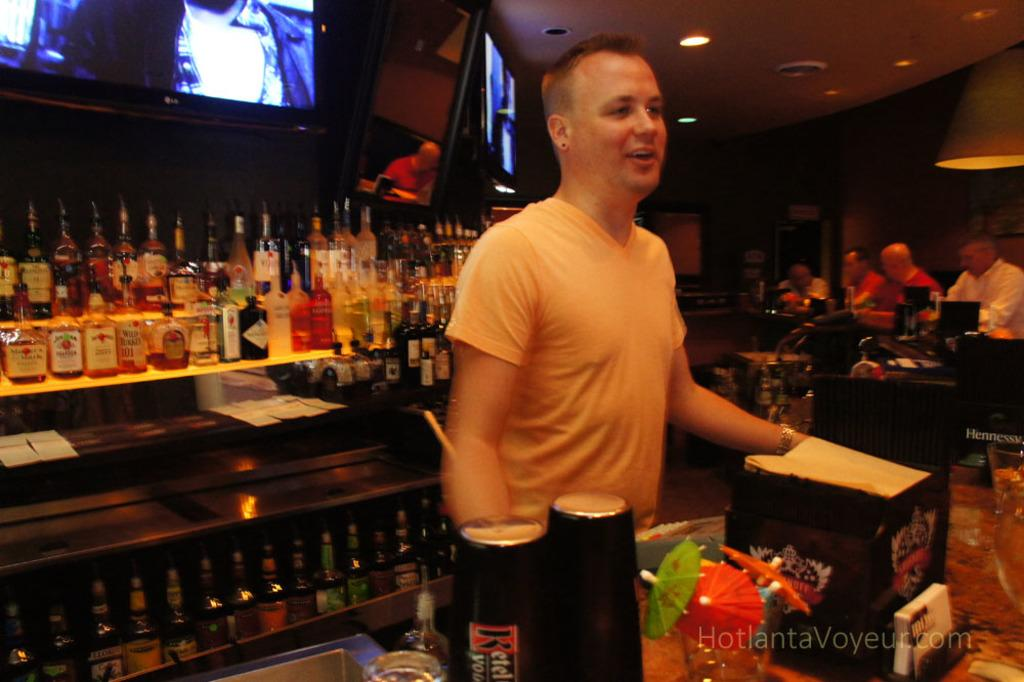<image>
Give a short and clear explanation of the subsequent image. A bartender in a white shirt with bottles of liquor behind him, some reading Maker's Mark and Wild Turkey 101. 